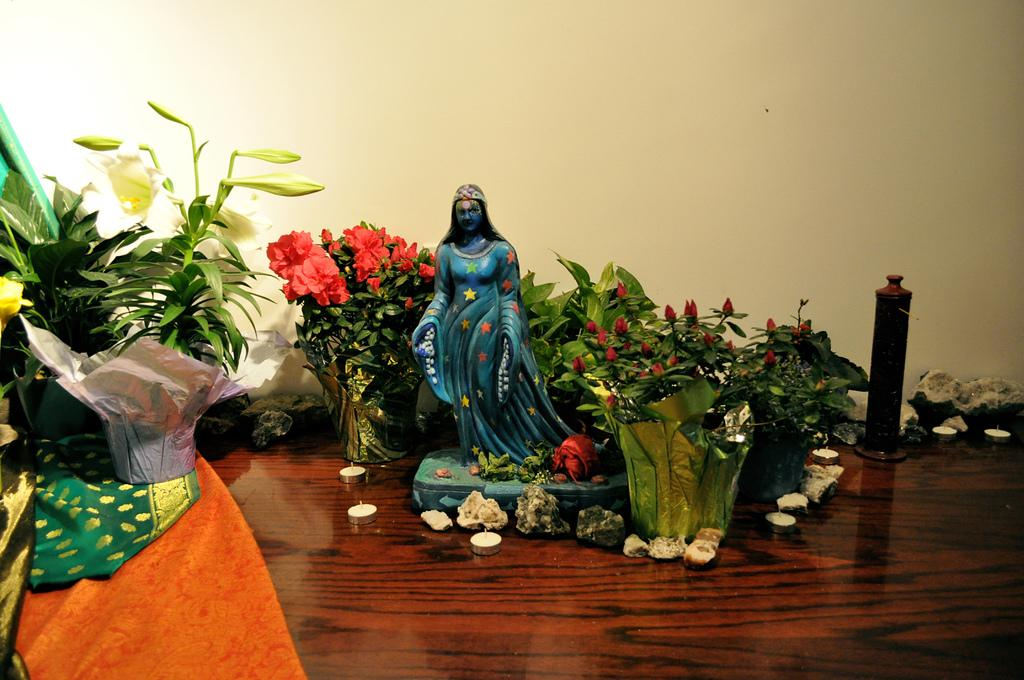What type of structure can be seen in the image? There is a wall in the image. What piece of furniture is present in the image? There is a table in the image. What is placed on the table in the image? There is a candle, plants, and a sculpture on the table. How many trucks are parked next to the wall in the image? There are no trucks present in the image; it only features a wall, a table, and items on the table. What type of paper is used to create the sculpture on the table? There is no paper mentioned in the image, and the sculpture is not described as being made of paper. 